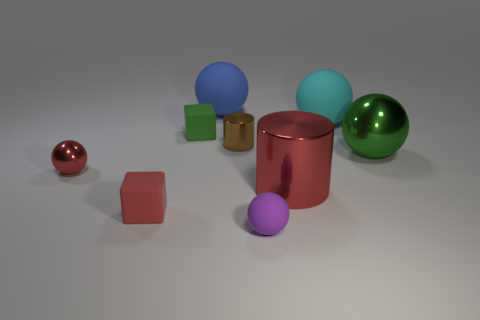What is the color of the tiny cylinder that is the same material as the large green object?
Give a very brief answer. Brown. There is a red rubber cube; how many tiny things are behind it?
Your answer should be compact. 3. Do the block that is behind the brown thing and the big shiny object that is behind the large cylinder have the same color?
Ensure brevity in your answer.  Yes. There is another tiny thing that is the same shape as the small green thing; what color is it?
Ensure brevity in your answer.  Red. Does the red thing right of the blue object have the same shape as the small matte object that is in front of the small red matte thing?
Your answer should be very brief. No. Is the size of the red sphere the same as the green thing in front of the green matte object?
Provide a succinct answer. No. Is the number of purple rubber things greater than the number of cubes?
Provide a short and direct response. No. Is the green thing to the right of the big metallic cylinder made of the same material as the green thing to the left of the cyan thing?
Offer a terse response. No. What is the material of the cyan object?
Your response must be concise. Rubber. Is the number of red blocks to the right of the small metal cylinder greater than the number of small metal spheres?
Ensure brevity in your answer.  No. 